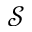<formula> <loc_0><loc_0><loc_500><loc_500>\mathcal { S }</formula> 